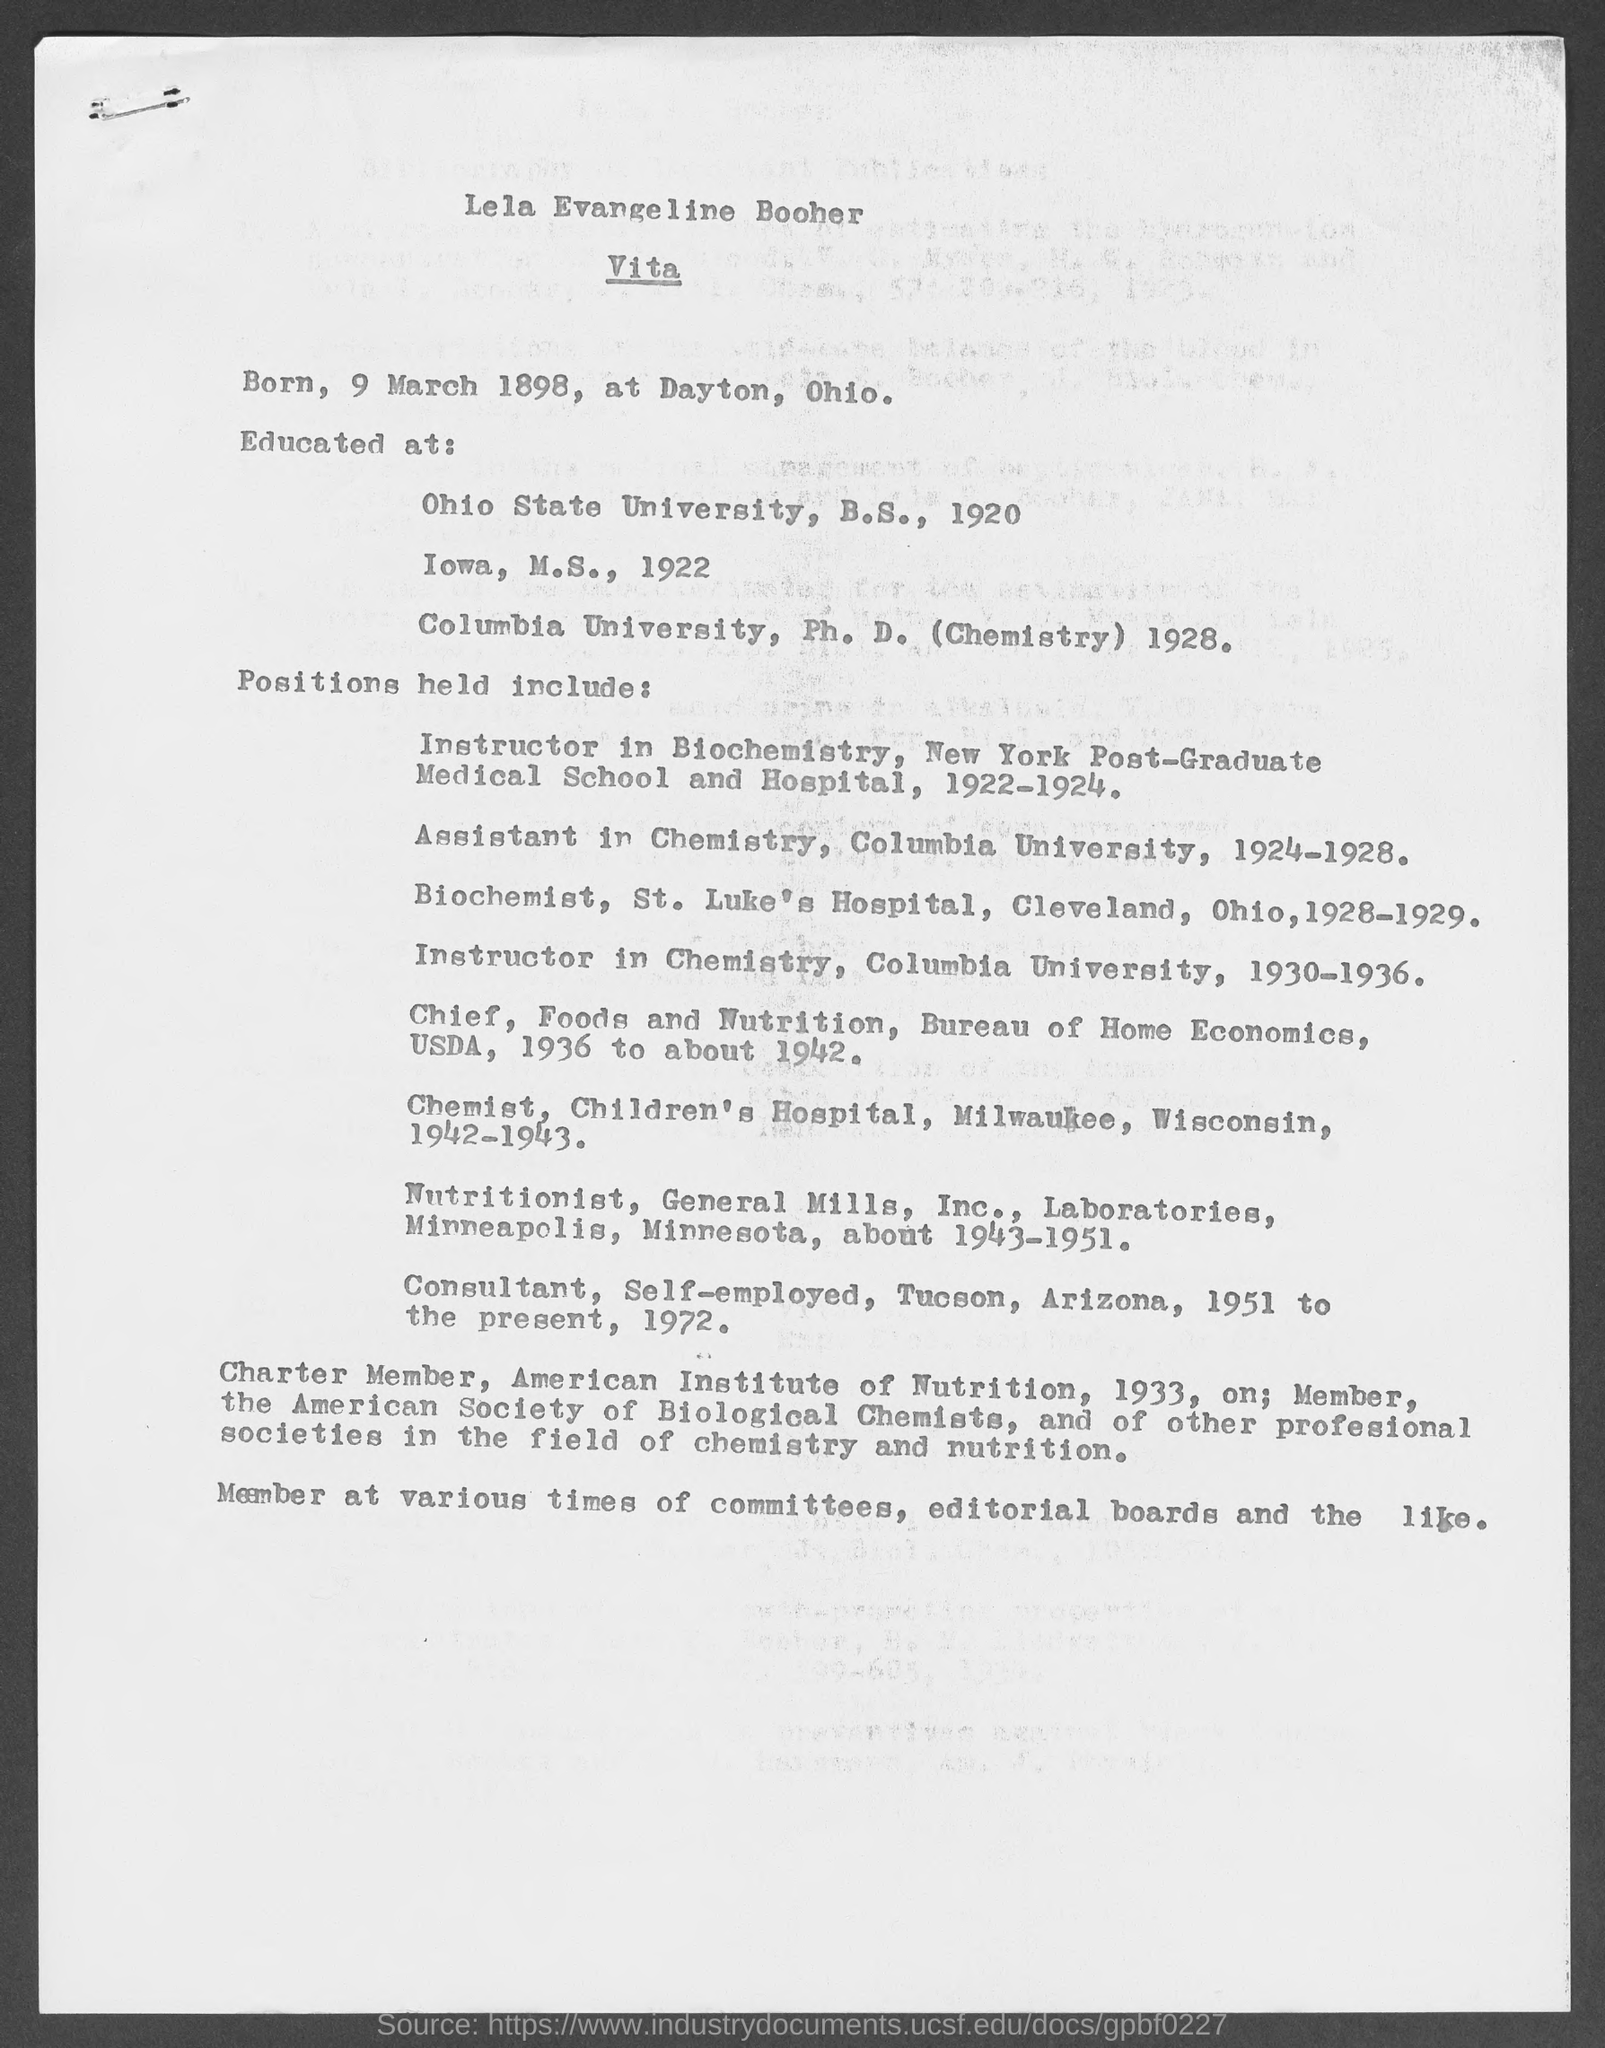Provide the name written at the top of the document?
Keep it short and to the point. Lela Evangeline Booher. Mention the heading given?
Ensure brevity in your answer.  Vita. Lela Evangeline Booher is "Born" on which date?
Your answer should be compact. 9 March 1898. Lela Evangeline Booher has done Ph. D from which "University" ?
Offer a very short reply. Columbia. Mention the highest qualification of Lela Evangeline Booher?
Ensure brevity in your answer.  Ph. D. (Chemistry). Lela Evangeline Booher held position of " Instructor in Biochemistry" during which period?
Your response must be concise. 1922-1924. Lela Evangeline Booher held position of " Assistant in Chemistry in Columbia University" during which period?
Ensure brevity in your answer.  1924-1928. Lela Evangeline Booher worked as " Instructor in chemistry" during which period?
Keep it short and to the point. 1930-1936. Lela Evangeline Booher worked as "Nutritionist" during which period?
Your answer should be compact. 1943-1951. 